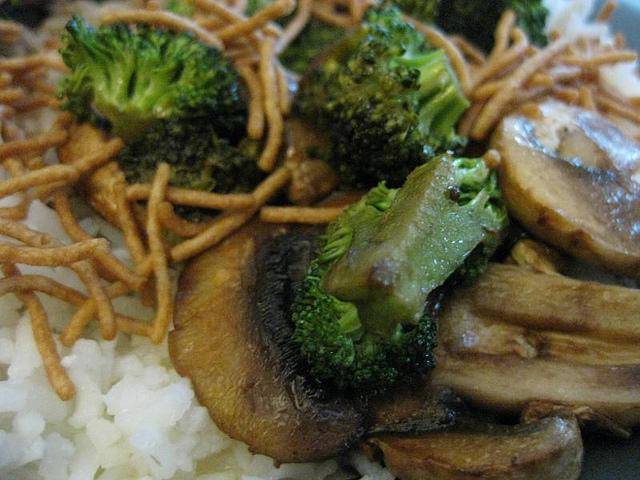What is the vegetable in this dish other than the broccoli? Please explain your reasoning. mushrooms. Mushrooms are right next to the broccoli. 